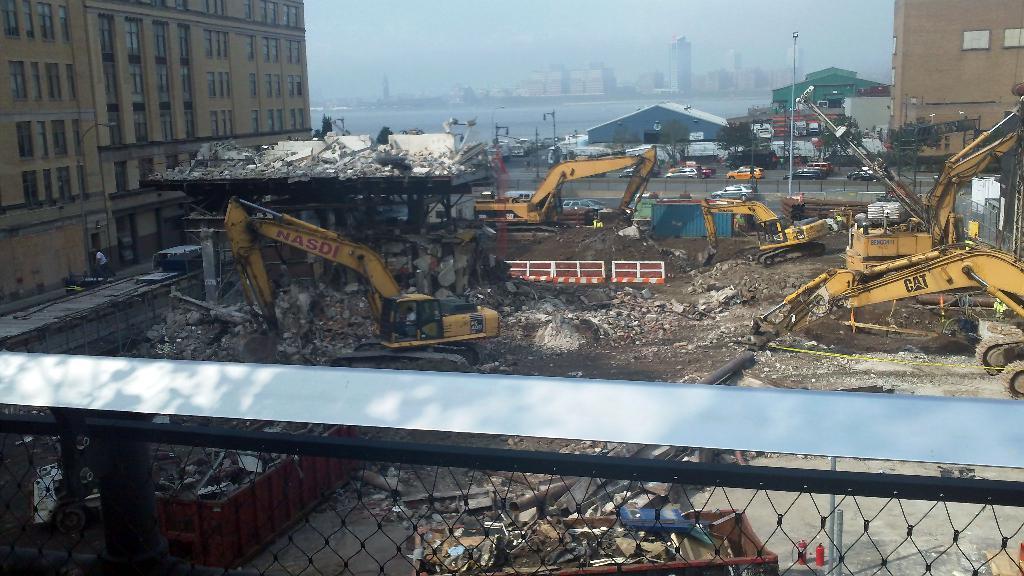Could you give a brief overview of what you see in this image? In this picture I can see fencing in front and in the middle of this picture I can see few buildings, few vehicles and I can see the road, on which there are vehicles and I see few poles. In the background I can see few more buildings and I can the sky. 